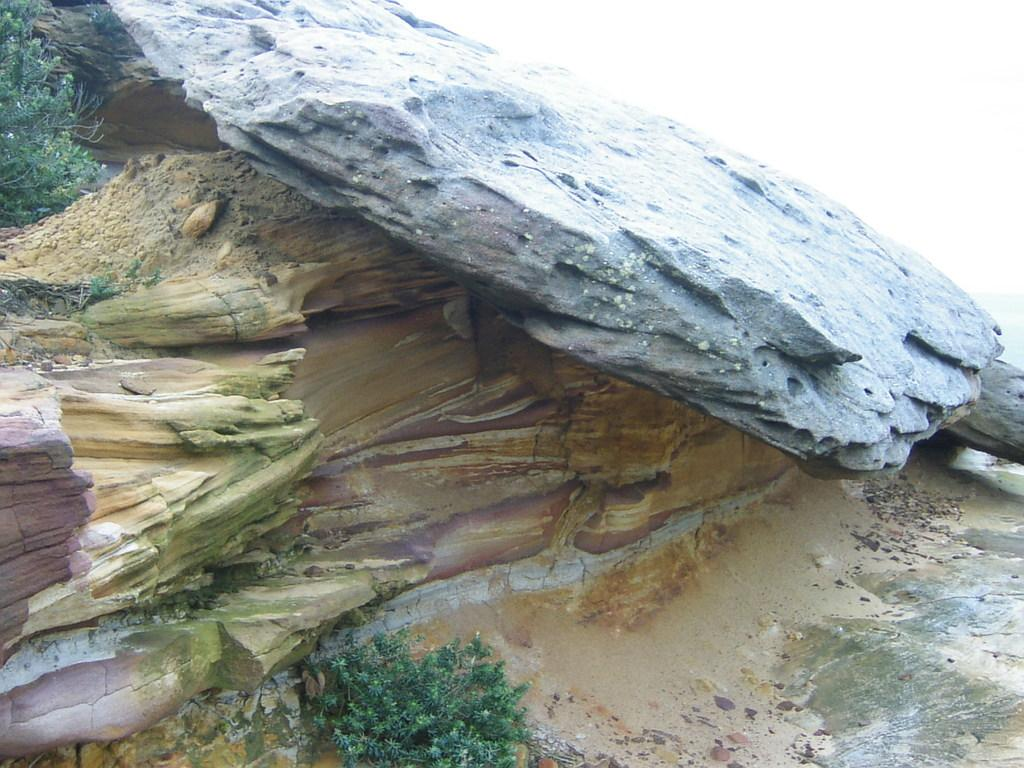What type of surface can be seen in the image? There is ground visible in the image. What is present on the ground? There are objects on the ground. What type of vegetation is in the image? There is grass and plants in the image. What other natural elements can be seen in the image? There are rocks in the image. What is visible above the ground and objects? The sky is visible in the image. What type of bell can be heard ringing in the image? There is no bell present in the image, and therefore no sound can be heard. 